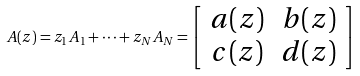Convert formula to latex. <formula><loc_0><loc_0><loc_500><loc_500>A ( z ) = z _ { 1 } A _ { 1 } + \cdots + z _ { N } A _ { N } = \left [ \begin{array} { c c } a ( z ) & b ( z ) \\ c ( z ) & d ( z ) \end{array} \right ]</formula> 